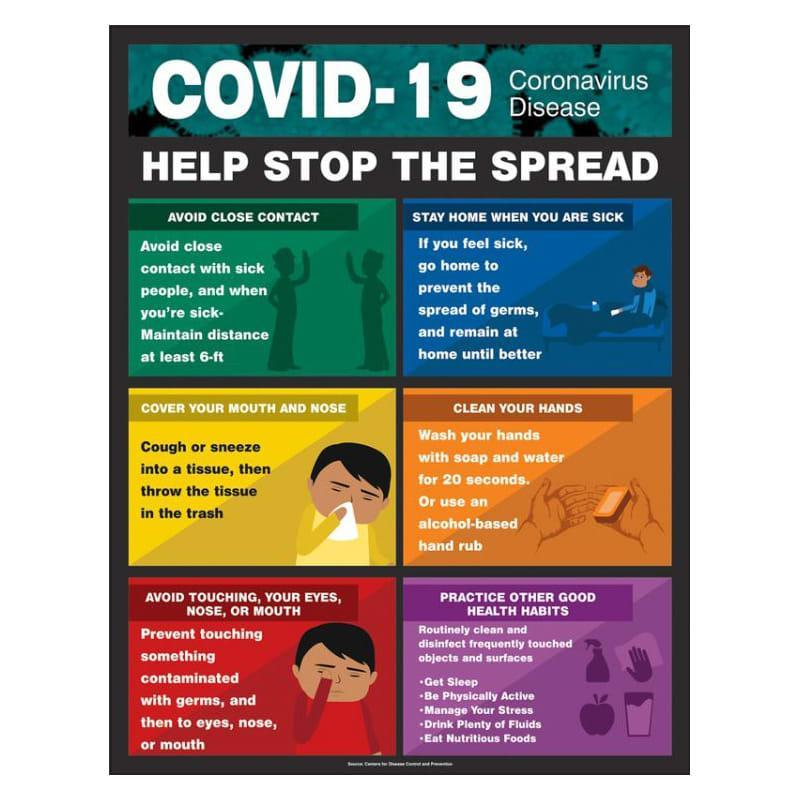How to dispose of used paper handkerchief?
Answer the question with a short phrase. throw the tissue in the trash Which is the fifth health practice listed in the infographic? Eat Nutritious Foods Which are the body parts to be careful about to prevent the corona virus? eyes, nose, or mouth Which is the third health practice listed in the infographic? Manage Your Stress Which is the second health practice listed in the infographic? Be Physically Active Which is the method to clean hands other than using soap or water? use an alcohol-based hand rub 